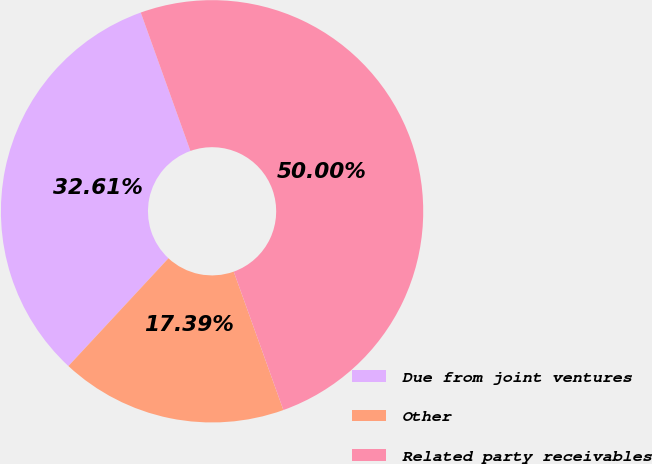Convert chart. <chart><loc_0><loc_0><loc_500><loc_500><pie_chart><fcel>Due from joint ventures<fcel>Other<fcel>Related party receivables<nl><fcel>32.61%<fcel>17.39%<fcel>50.0%<nl></chart> 